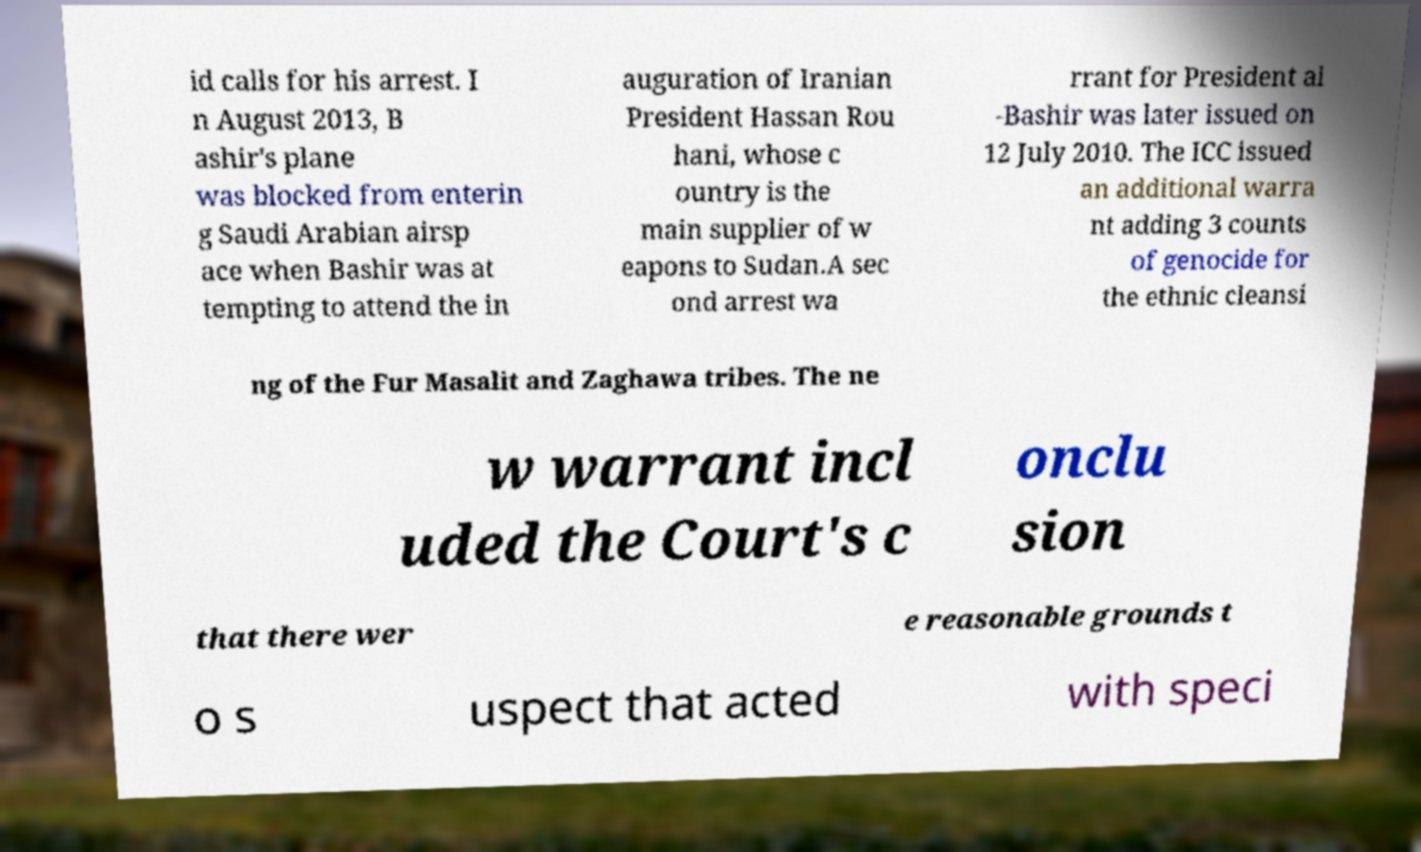Could you extract and type out the text from this image? id calls for his arrest. I n August 2013, B ashir's plane was blocked from enterin g Saudi Arabian airsp ace when Bashir was at tempting to attend the in auguration of Iranian President Hassan Rou hani, whose c ountry is the main supplier of w eapons to Sudan.A sec ond arrest wa rrant for President al -Bashir was later issued on 12 July 2010. The ICC issued an additional warra nt adding 3 counts of genocide for the ethnic cleansi ng of the Fur Masalit and Zaghawa tribes. The ne w warrant incl uded the Court's c onclu sion that there wer e reasonable grounds t o s uspect that acted with speci 